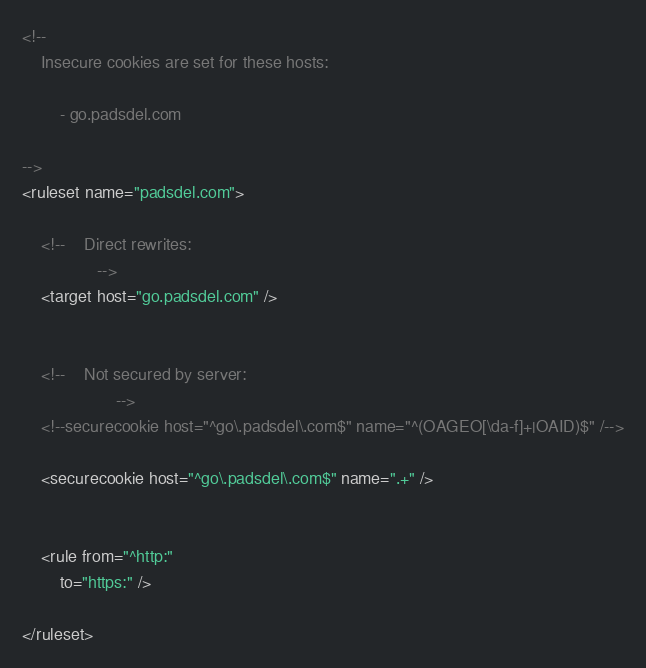Convert code to text. <code><loc_0><loc_0><loc_500><loc_500><_XML_><!--
	Insecure cookies are set for these hosts:

		- go.padsdel.com

-->
<ruleset name="padsdel.com">

	<!--	Direct rewrites:
				-->
	<target host="go.padsdel.com" />


	<!--	Not secured by server:
					-->
	<!--securecookie host="^go\.padsdel\.com$" name="^(OAGEO[\da-f]+|OAID)$" /-->

	<securecookie host="^go\.padsdel\.com$" name=".+" />


	<rule from="^http:"
		to="https:" />

</ruleset>
</code> 